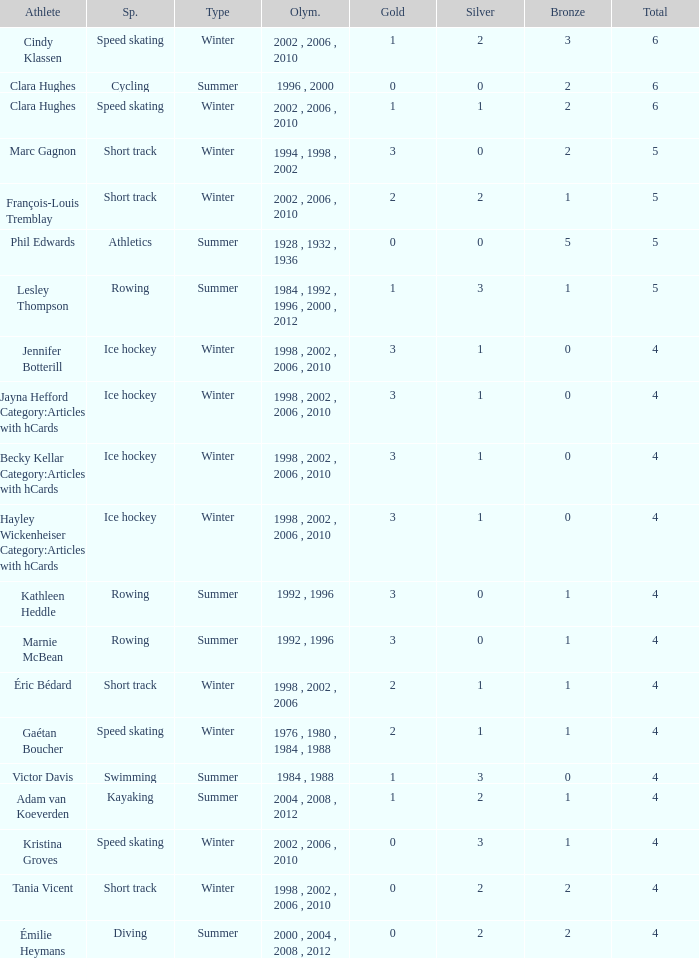What is the average gold of the winter athlete with 1 bronze, less than 3 silver, and less than 4 total medals? None. 